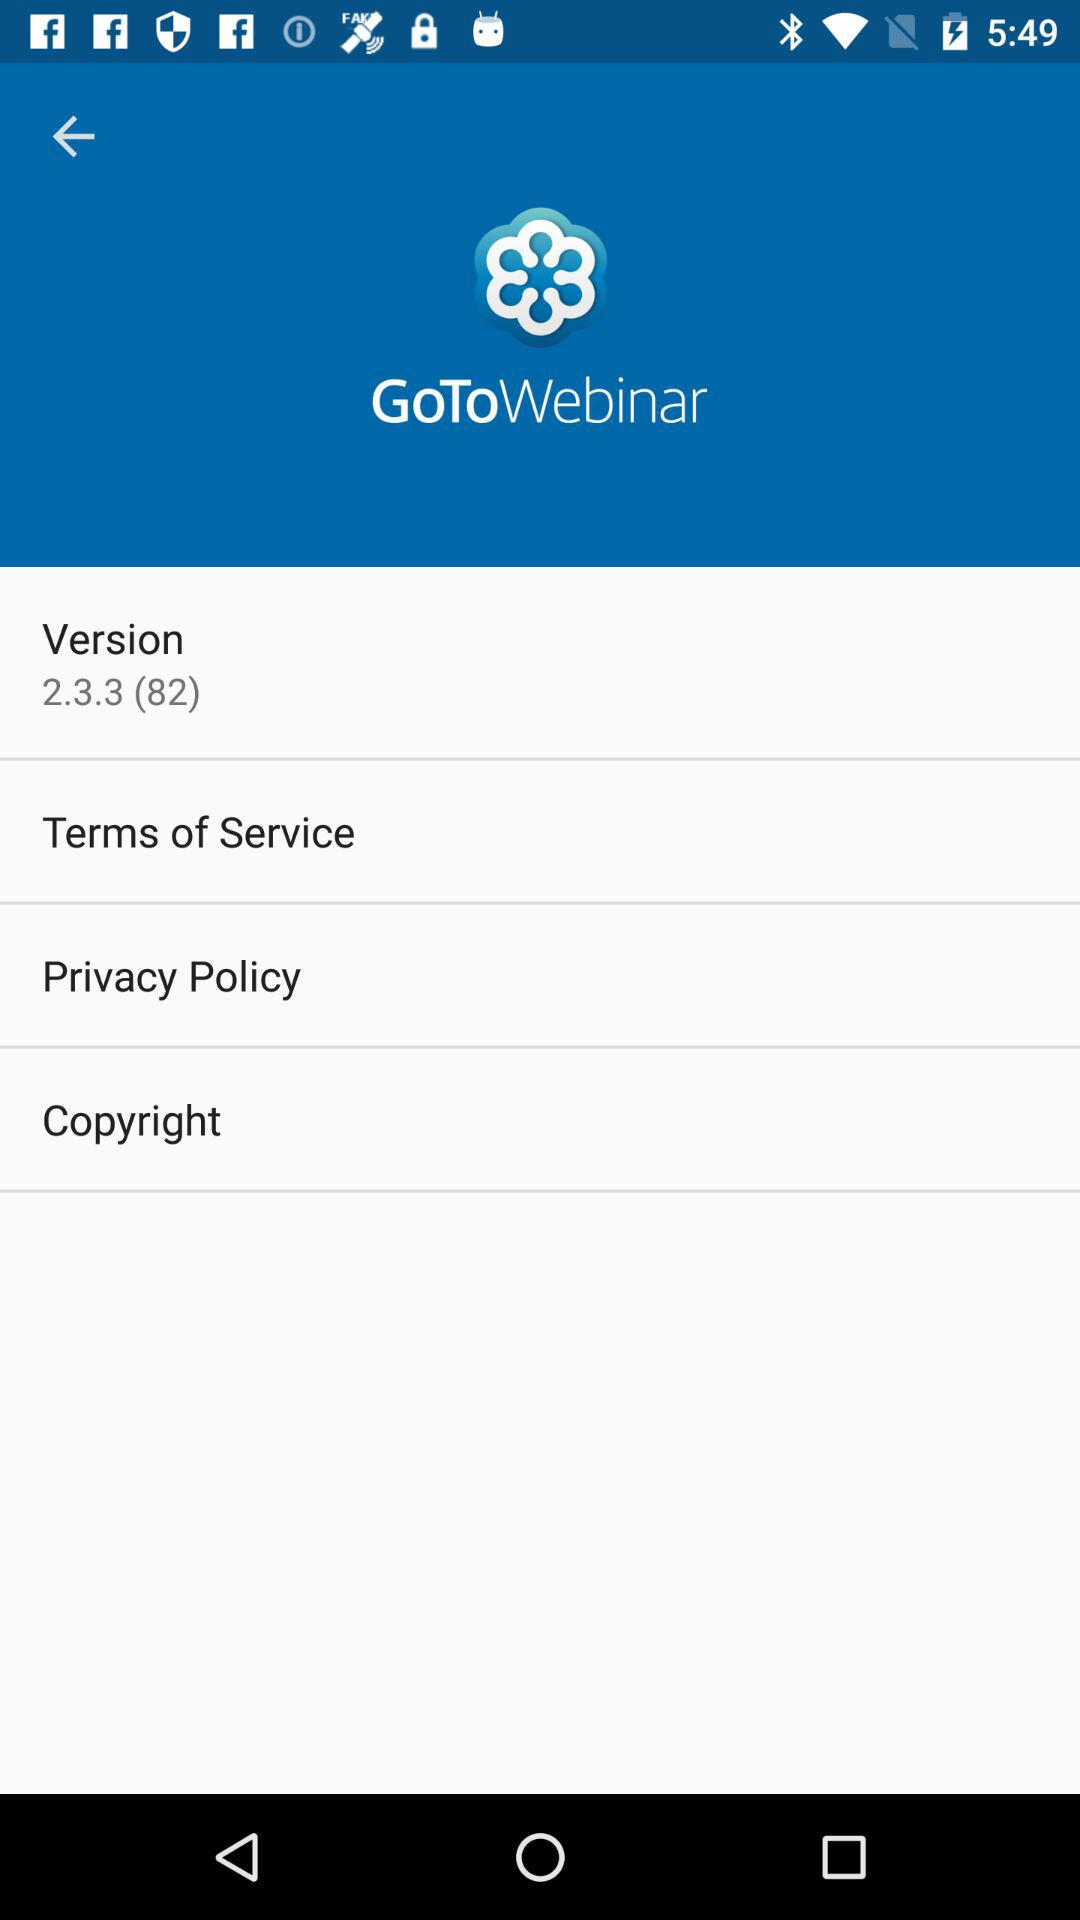What is the version of "GoToWebinar"? The version of "GoToWebinar" is 2.3.3 (82). 